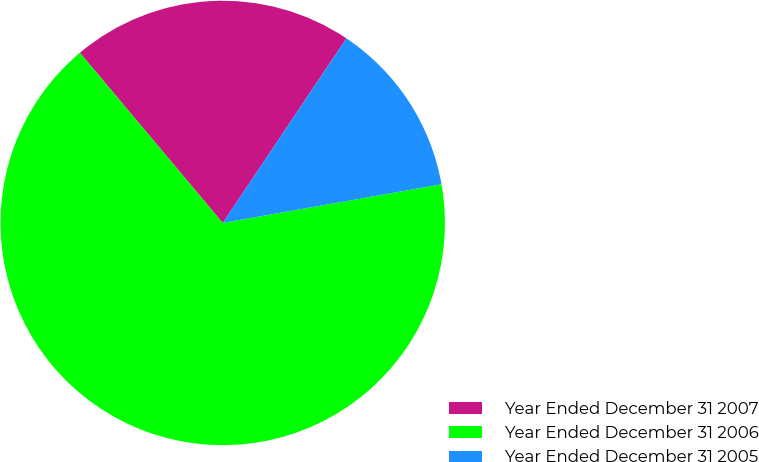Convert chart to OTSL. <chart><loc_0><loc_0><loc_500><loc_500><pie_chart><fcel>Year Ended December 31 2007<fcel>Year Ended December 31 2006<fcel>Year Ended December 31 2005<nl><fcel>20.51%<fcel>66.67%<fcel>12.82%<nl></chart> 